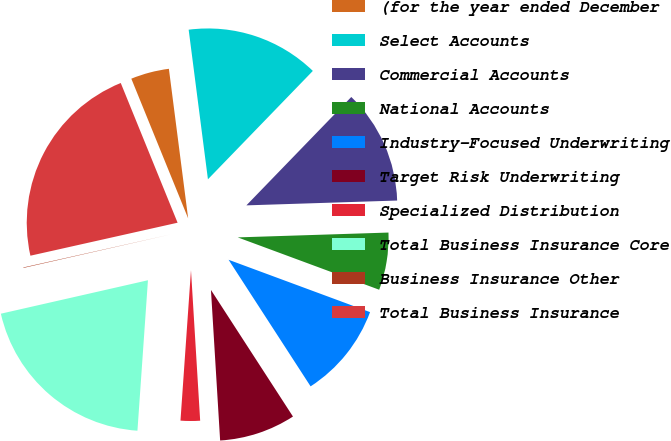Convert chart to OTSL. <chart><loc_0><loc_0><loc_500><loc_500><pie_chart><fcel>(for the year ended December<fcel>Select Accounts<fcel>Commercial Accounts<fcel>National Accounts<fcel>Industry-Focused Underwriting<fcel>Target Risk Underwriting<fcel>Specialized Distribution<fcel>Total Business Insurance Core<fcel>Business Insurance Other<fcel>Total Business Insurance<nl><fcel>4.11%<fcel>14.28%<fcel>12.25%<fcel>6.15%<fcel>10.21%<fcel>8.18%<fcel>2.08%<fcel>20.33%<fcel>0.05%<fcel>22.36%<nl></chart> 